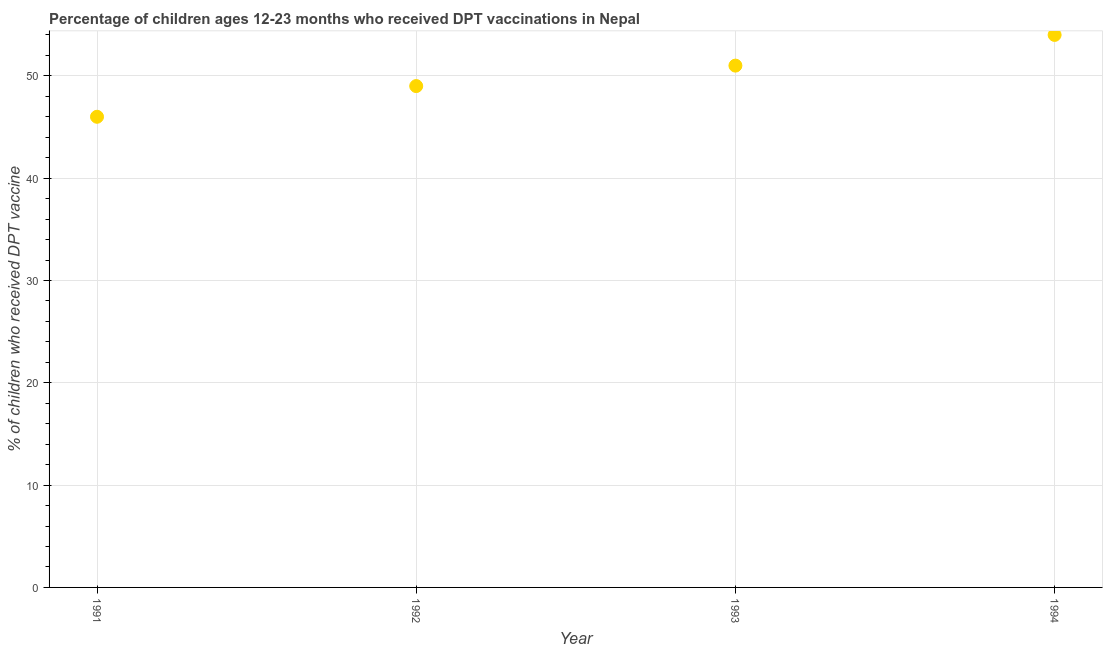What is the percentage of children who received dpt vaccine in 1993?
Give a very brief answer. 51. Across all years, what is the maximum percentage of children who received dpt vaccine?
Offer a very short reply. 54. Across all years, what is the minimum percentage of children who received dpt vaccine?
Offer a very short reply. 46. In which year was the percentage of children who received dpt vaccine maximum?
Provide a succinct answer. 1994. What is the sum of the percentage of children who received dpt vaccine?
Your answer should be compact. 200. What is the difference between the percentage of children who received dpt vaccine in 1991 and 1992?
Your response must be concise. -3. Do a majority of the years between 1991 and 1993 (inclusive) have percentage of children who received dpt vaccine greater than 36 %?
Give a very brief answer. Yes. What is the ratio of the percentage of children who received dpt vaccine in 1993 to that in 1994?
Keep it short and to the point. 0.94. Is the percentage of children who received dpt vaccine in 1991 less than that in 1992?
Make the answer very short. Yes. What is the difference between the highest and the lowest percentage of children who received dpt vaccine?
Offer a terse response. 8. In how many years, is the percentage of children who received dpt vaccine greater than the average percentage of children who received dpt vaccine taken over all years?
Your response must be concise. 2. Does the percentage of children who received dpt vaccine monotonically increase over the years?
Ensure brevity in your answer.  Yes. How many years are there in the graph?
Keep it short and to the point. 4. Are the values on the major ticks of Y-axis written in scientific E-notation?
Your answer should be compact. No. Does the graph contain any zero values?
Your response must be concise. No. Does the graph contain grids?
Make the answer very short. Yes. What is the title of the graph?
Provide a short and direct response. Percentage of children ages 12-23 months who received DPT vaccinations in Nepal. What is the label or title of the X-axis?
Provide a short and direct response. Year. What is the label or title of the Y-axis?
Provide a succinct answer. % of children who received DPT vaccine. What is the % of children who received DPT vaccine in 1992?
Ensure brevity in your answer.  49. What is the % of children who received DPT vaccine in 1994?
Ensure brevity in your answer.  54. What is the difference between the % of children who received DPT vaccine in 1991 and 1992?
Ensure brevity in your answer.  -3. What is the difference between the % of children who received DPT vaccine in 1992 and 1993?
Provide a short and direct response. -2. What is the difference between the % of children who received DPT vaccine in 1992 and 1994?
Ensure brevity in your answer.  -5. What is the difference between the % of children who received DPT vaccine in 1993 and 1994?
Make the answer very short. -3. What is the ratio of the % of children who received DPT vaccine in 1991 to that in 1992?
Offer a terse response. 0.94. What is the ratio of the % of children who received DPT vaccine in 1991 to that in 1993?
Your response must be concise. 0.9. What is the ratio of the % of children who received DPT vaccine in 1991 to that in 1994?
Make the answer very short. 0.85. What is the ratio of the % of children who received DPT vaccine in 1992 to that in 1994?
Give a very brief answer. 0.91. What is the ratio of the % of children who received DPT vaccine in 1993 to that in 1994?
Your response must be concise. 0.94. 